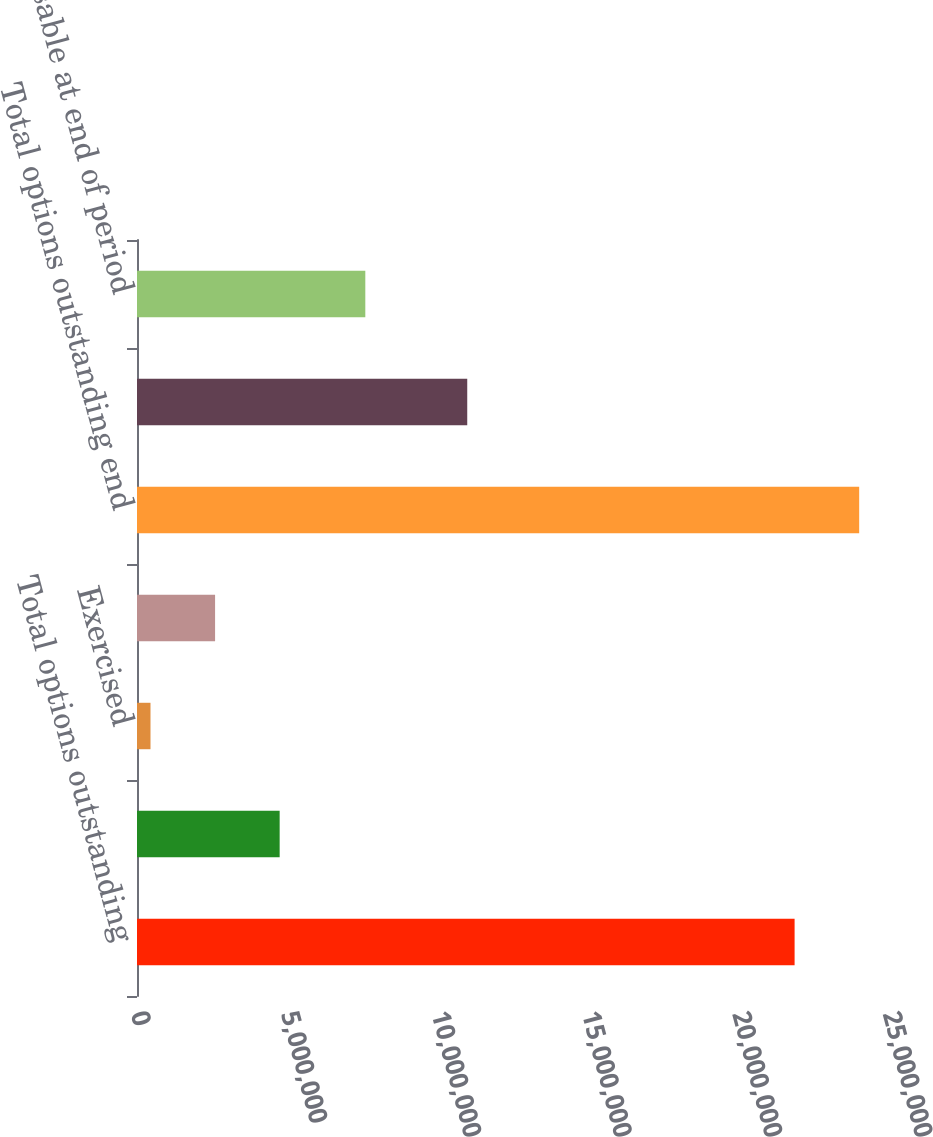Convert chart. <chart><loc_0><loc_0><loc_500><loc_500><bar_chart><fcel>Total options outstanding<fcel>Granted<fcel>Exercised<fcel>Forfeited and cancelled<fcel>Total options outstanding end<fcel>Performance based options<fcel>Exercisable at end of period<nl><fcel>2.18617e+07<fcel>4.74268e+06<fcel>448729<fcel>2.59571e+06<fcel>2.40087e+07<fcel>1.09788e+07<fcel>7.59026e+06<nl></chart> 